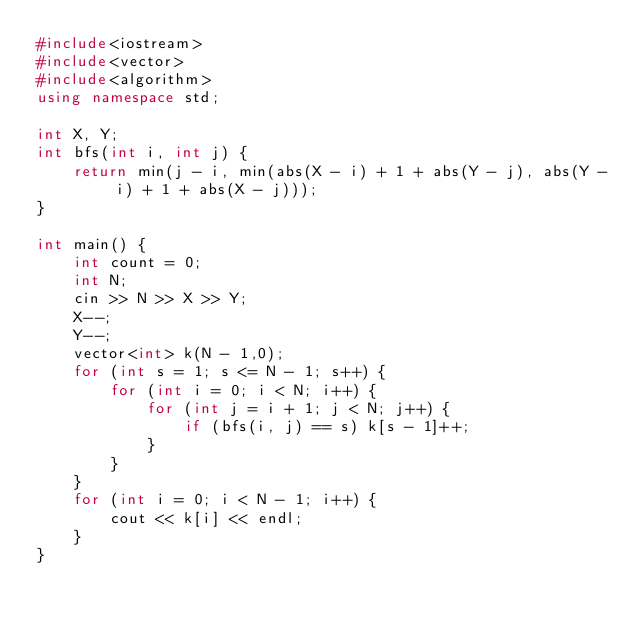Convert code to text. <code><loc_0><loc_0><loc_500><loc_500><_C++_>#include<iostream>
#include<vector>
#include<algorithm>
using namespace std;

int X, Y;
int bfs(int i, int j) {
	return min(j - i, min(abs(X - i) + 1 + abs(Y - j), abs(Y - i) + 1 + abs(X - j)));
}

int main() {
	int count = 0;
	int N;
	cin >> N >> X >> Y;
	X--;
	Y--;
	vector<int> k(N - 1,0);
	for (int s = 1; s <= N - 1; s++) {
		for (int i = 0; i < N; i++) {
			for (int j = i + 1; j < N; j++) {
				if (bfs(i, j) == s) k[s - 1]++;
			}
		}
	}
	for (int i = 0; i < N - 1; i++) {
		cout << k[i] << endl;
	}
}</code> 